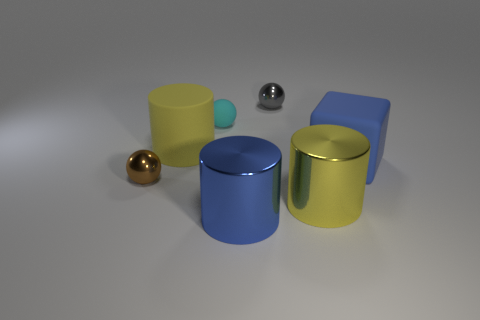What is the shape of the thing that is the same color as the big matte cylinder?
Your answer should be compact. Cylinder. Is the brown object made of the same material as the yellow cylinder to the right of the small cyan rubber thing?
Your answer should be compact. Yes. What is the shape of the tiny thing that is the same material as the big cube?
Ensure brevity in your answer.  Sphere. There is another metallic object that is the same size as the gray thing; what color is it?
Your answer should be compact. Brown. Do the yellow object that is in front of the brown object and the large blue matte cube have the same size?
Provide a succinct answer. Yes. Do the tiny matte thing and the matte cube have the same color?
Give a very brief answer. No. How many blue balls are there?
Provide a short and direct response. 0. What number of spheres are small brown things or tiny yellow matte things?
Provide a short and direct response. 1. There is a shiny object that is behind the rubber sphere; what number of large rubber cylinders are in front of it?
Keep it short and to the point. 1. Is the blue cylinder made of the same material as the block?
Provide a succinct answer. No. 